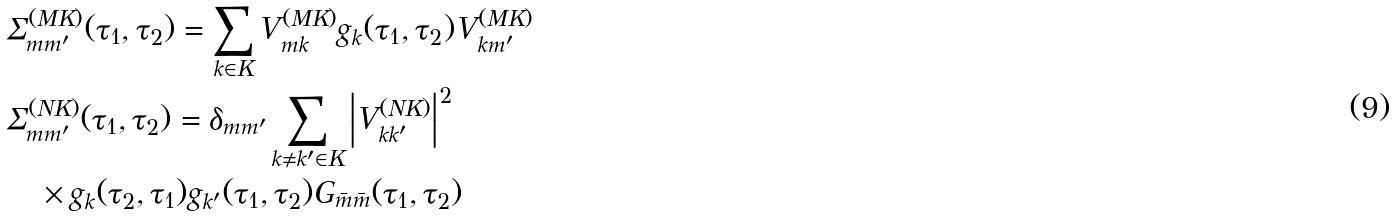<formula> <loc_0><loc_0><loc_500><loc_500>& \Sigma ^ { ( M K ) } _ { m m ^ { \prime } } ( \tau _ { 1 } , \tau _ { 2 } ) = \sum _ { k \in K } V _ { m k } ^ { ( M K ) } g _ { k } ( \tau _ { 1 } , \tau _ { 2 } ) V _ { k m ^ { \prime } } ^ { ( M K ) } \\ & \Sigma ^ { ( N K ) } _ { m m ^ { \prime } } ( \tau _ { 1 } , \tau _ { 2 } ) = \delta _ { m m ^ { \prime } } \sum _ { k \neq k ^ { \prime } \in K } \left | V _ { k k ^ { \prime } } ^ { ( N K ) } \right | ^ { 2 } \\ & \quad \times g _ { k } ( \tau _ { 2 } , \tau _ { 1 } ) g _ { k ^ { \prime } } ( \tau _ { 1 } , \tau _ { 2 } ) G _ { \bar { m } \bar { m } } ( \tau _ { 1 } , \tau _ { 2 } )</formula> 